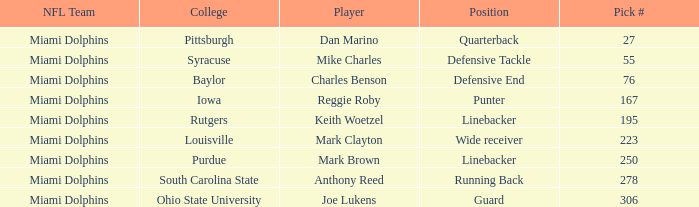If the Position is Running Back what is the Total number of Pick #? 1.0. 